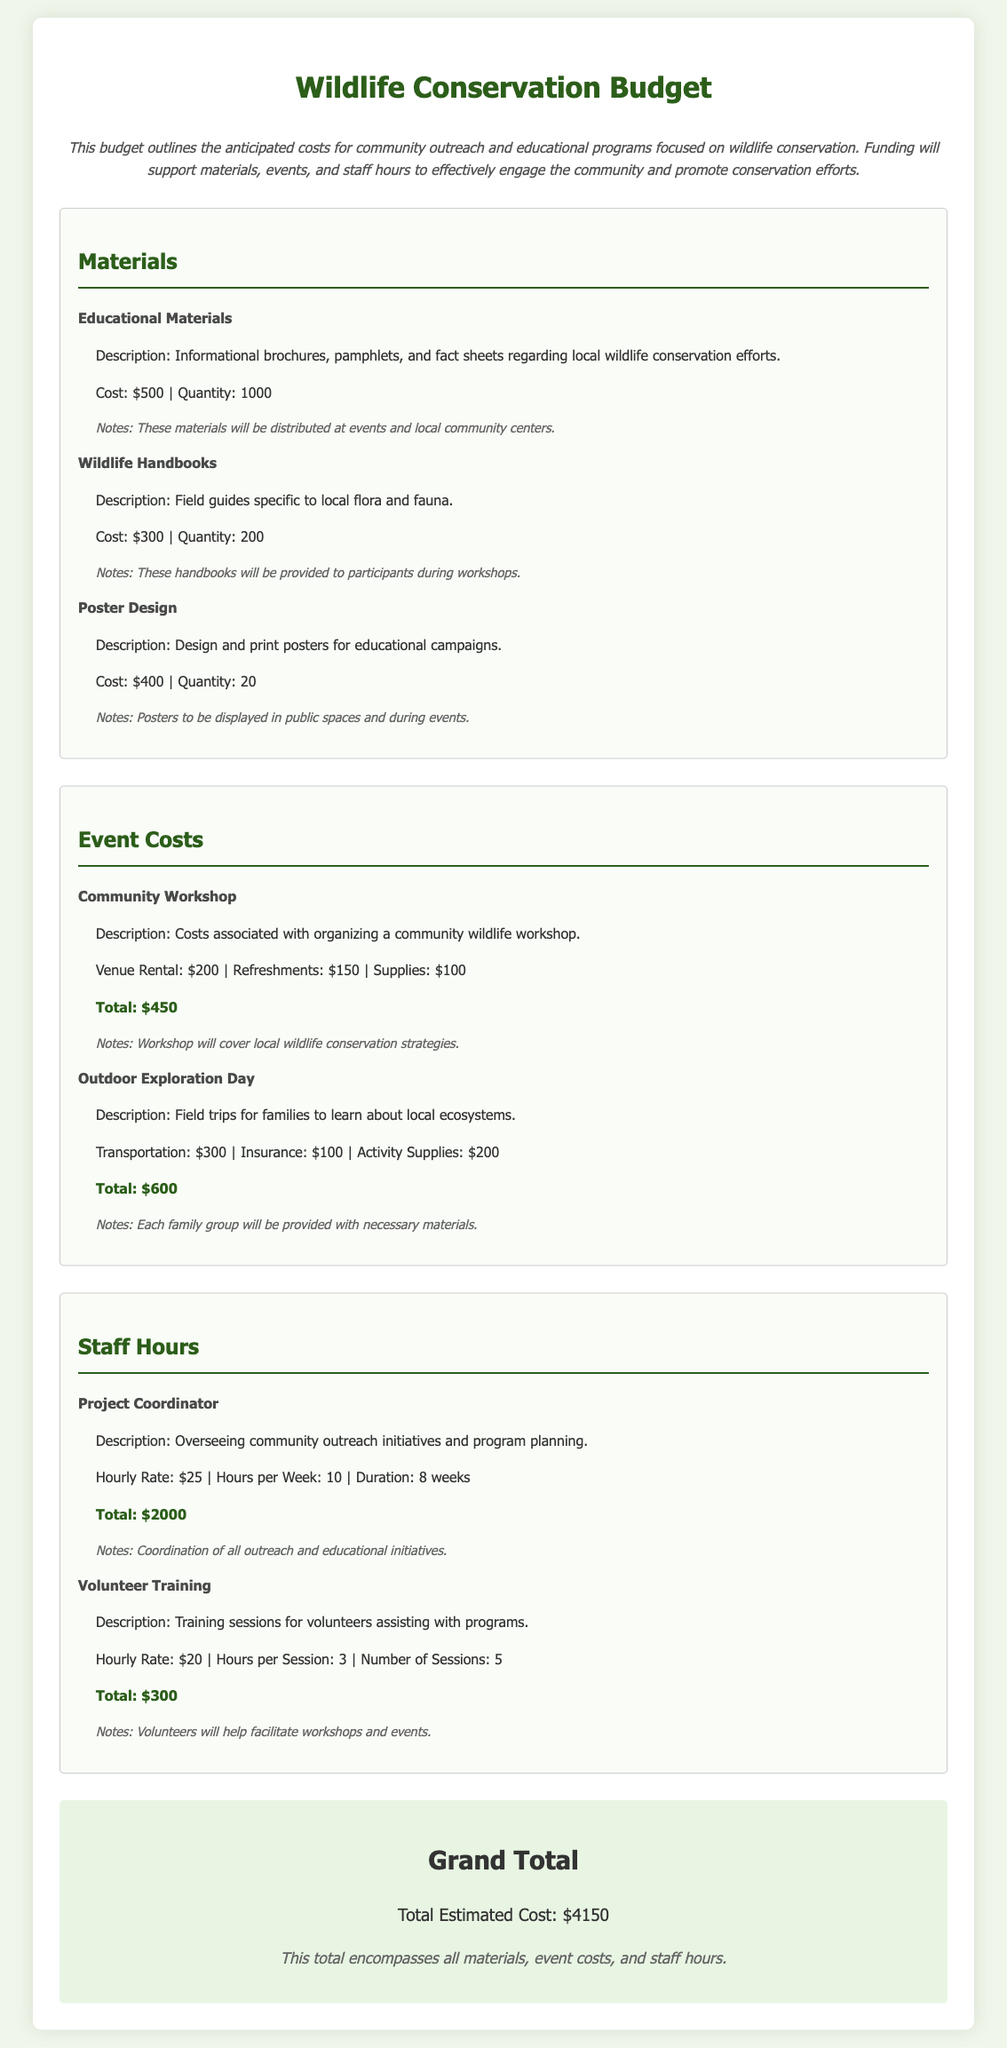what is the cost of educational materials? The cost of educational materials is specified in the document as $500 for 1000 brochures, pamphlets, and fact sheets.
Answer: $500 how many wildlife handbooks are planned for distribution? The document states that there will be 200 wildlife handbooks provided to participants during workshops.
Answer: 200 what is the total cost for the community workshop? All costs associated with the community workshop, including venue rental, refreshments, and supplies, add up to a total of $450.
Answer: $450 what is the hourly rate for the project coordinator? The document specifies the project coordinator's hourly rate as $25.
Answer: $25 how many sessions of volunteer training are planned? The total number of volunteer training sessions indicated in the document is 5.
Answer: 5 what is the total estimated cost for all outreach initiatives? The total estimated cost for all materials, event costs, and staff hours summed up to $4150.
Answer: $4150 what type of materials will be distributed at events? The document mentions that informational brochures, pamphlets, and fact sheets will be distributed at events.
Answer: Informational brochures, pamphlets, and fact sheets what is the total cost of the Outdoor Exploration Day? The expenses for the Outdoor Exploration Day include transportation, insurance, and activity supplies, totaling $600.
Answer: $600 what is the cost of poster design? The cost mentioned in the document for designing and printing posters is $400 for 20 posters.
Answer: $400 